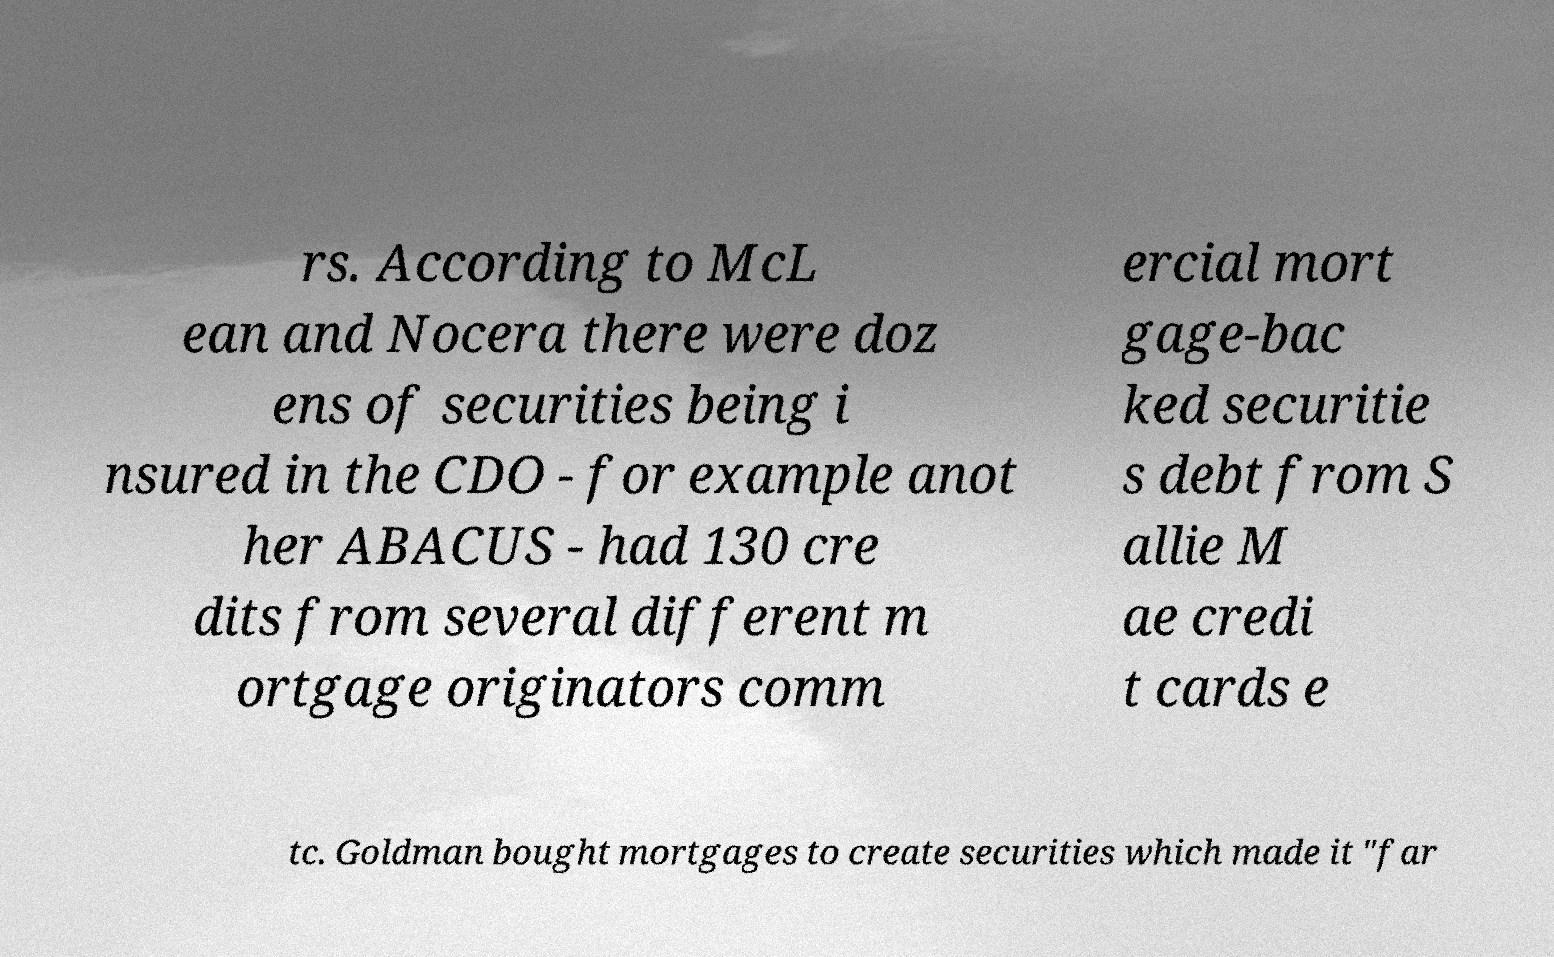Can you accurately transcribe the text from the provided image for me? rs. According to McL ean and Nocera there were doz ens of securities being i nsured in the CDO - for example anot her ABACUS - had 130 cre dits from several different m ortgage originators comm ercial mort gage-bac ked securitie s debt from S allie M ae credi t cards e tc. Goldman bought mortgages to create securities which made it "far 